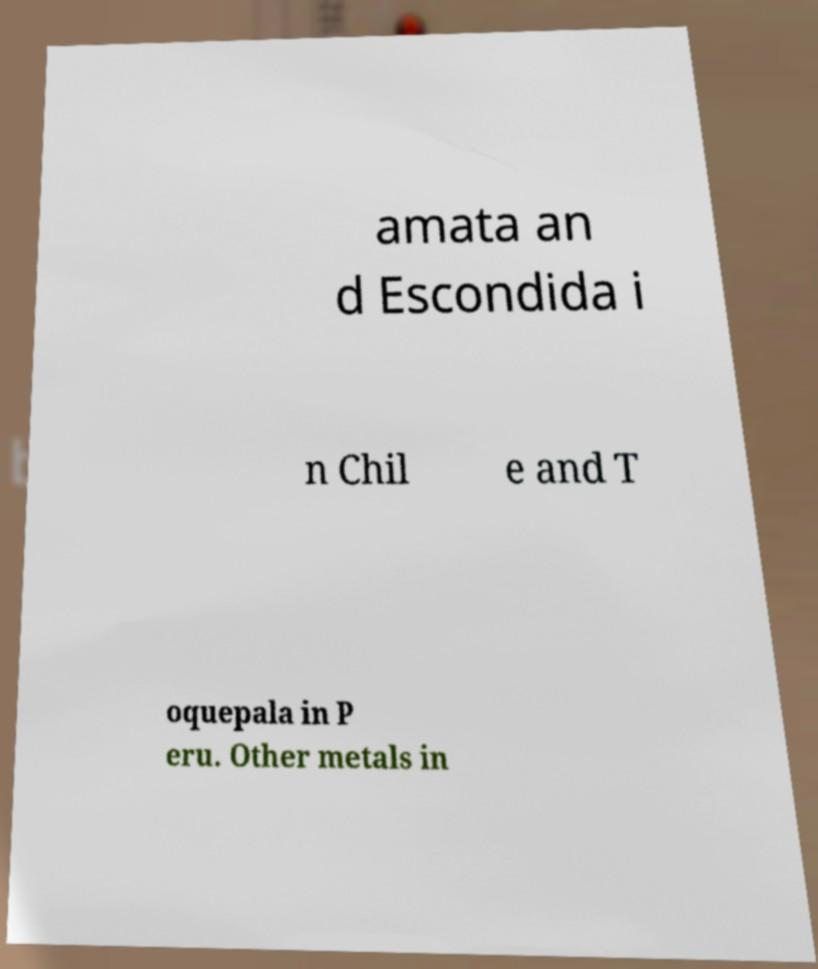Please read and relay the text visible in this image. What does it say? amata an d Escondida i n Chil e and T oquepala in P eru. Other metals in 